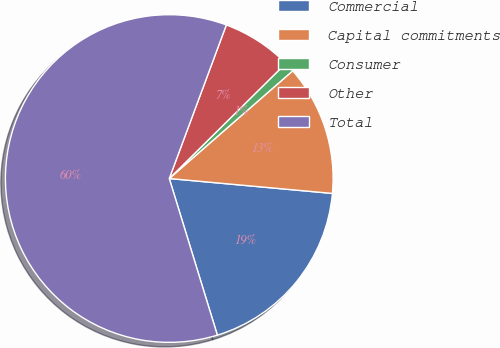Convert chart. <chart><loc_0><loc_0><loc_500><loc_500><pie_chart><fcel>Commercial<fcel>Capital commitments<fcel>Consumer<fcel>Other<fcel>Total<nl><fcel>18.81%<fcel>12.87%<fcel>0.99%<fcel>6.93%<fcel>60.41%<nl></chart> 